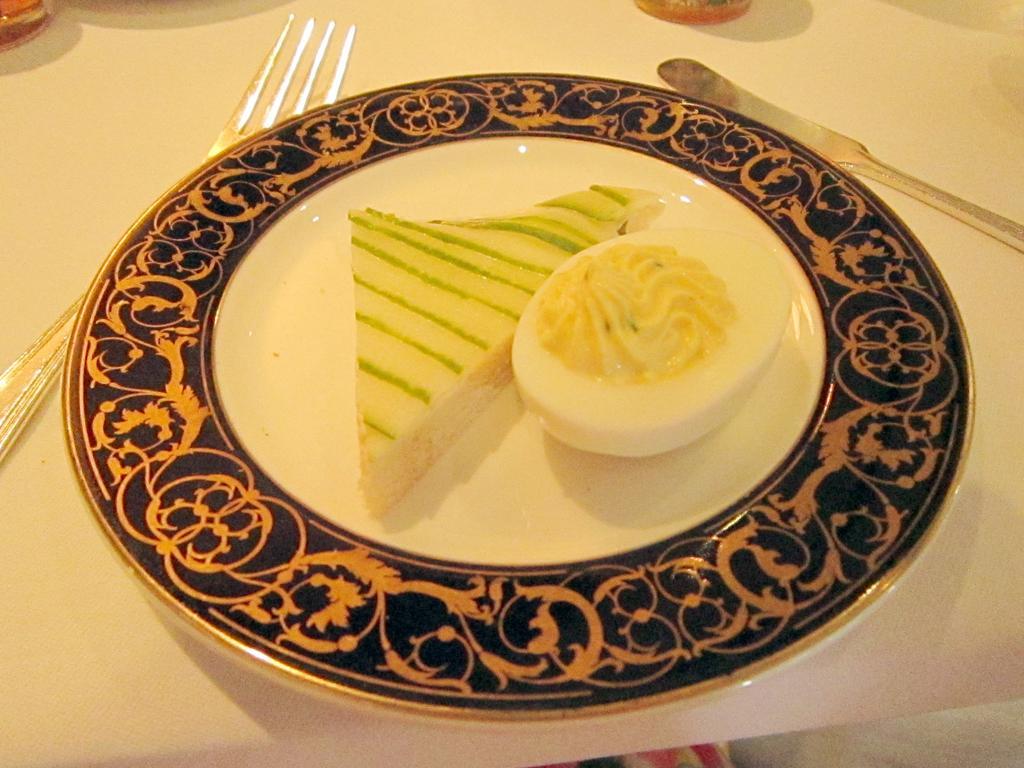Can you describe this image briefly? In the picture we can see a table on it, we can see a plate with a sandwich and an egg slice on it and besides to the plate we can see a fork and knife. 